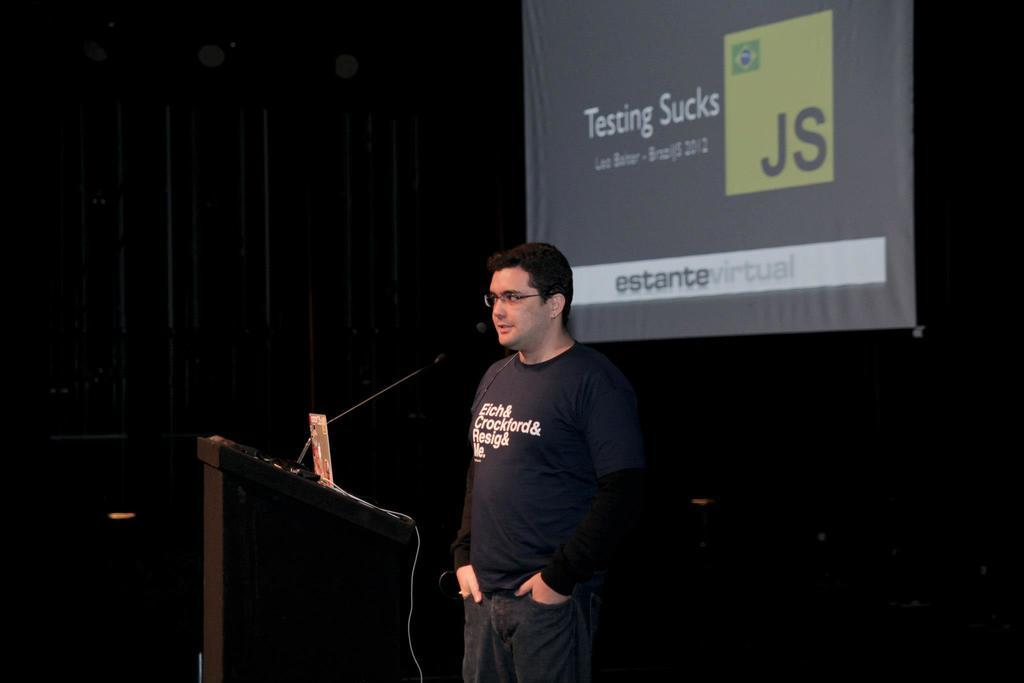What is the main object in the middle of the image? There is a podium in the middle of the image. What is on the podium? A microphone and a laptop are present on the podium. Who is near the podium? There is a man standing near the podium. What is behind the man? There is a cloth and a screen behind the man. Can you see any firemen in the image? There are no firemen present in the image. Is there a lake visible in the image? There is no lake present in the image. 